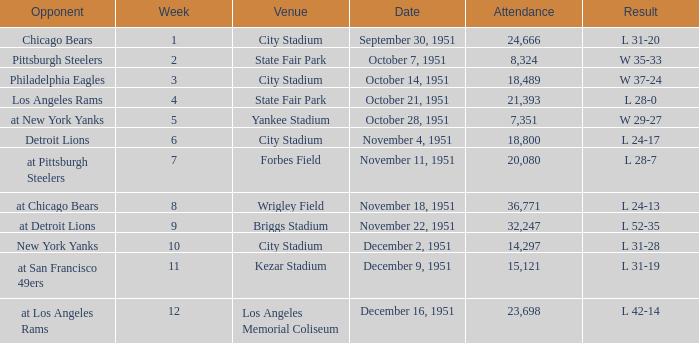Which date's week was more than 4 with the venue being City Stadium and where the attendance was more than 14,297? November 4, 1951. 